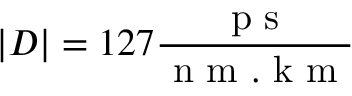Convert formula to latex. <formula><loc_0><loc_0><loc_500><loc_500>| D | = 1 2 7 \frac { p s } { n m . k m }</formula> 